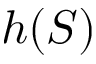<formula> <loc_0><loc_0><loc_500><loc_500>h ( S )</formula> 